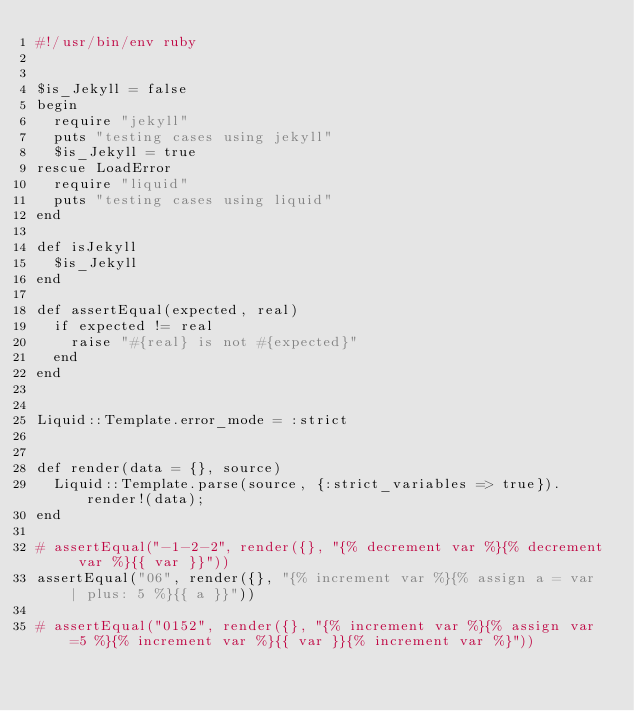Convert code to text. <code><loc_0><loc_0><loc_500><loc_500><_Ruby_>#!/usr/bin/env ruby


$is_Jekyll = false
begin
  require "jekyll"
  puts "testing cases using jekyll"
  $is_Jekyll = true
rescue LoadError
  require "liquid"
  puts "testing cases using liquid"
end

def isJekyll
  $is_Jekyll
end

def assertEqual(expected, real)
  if expected != real
    raise "#{real} is not #{expected}"
  end
end


Liquid::Template.error_mode = :strict


def render(data = {}, source)
  Liquid::Template.parse(source, {:strict_variables => true}).render!(data);
end

# assertEqual("-1-2-2", render({}, "{% decrement var %}{% decrement var %}{{ var }}"))
assertEqual("06", render({}, "{% increment var %}{% assign a = var | plus: 5 %}{{ a }}"))

# assertEqual("0152", render({}, "{% increment var %}{% assign var=5 %}{% increment var %}{{ var }}{% increment var %}"))</code> 